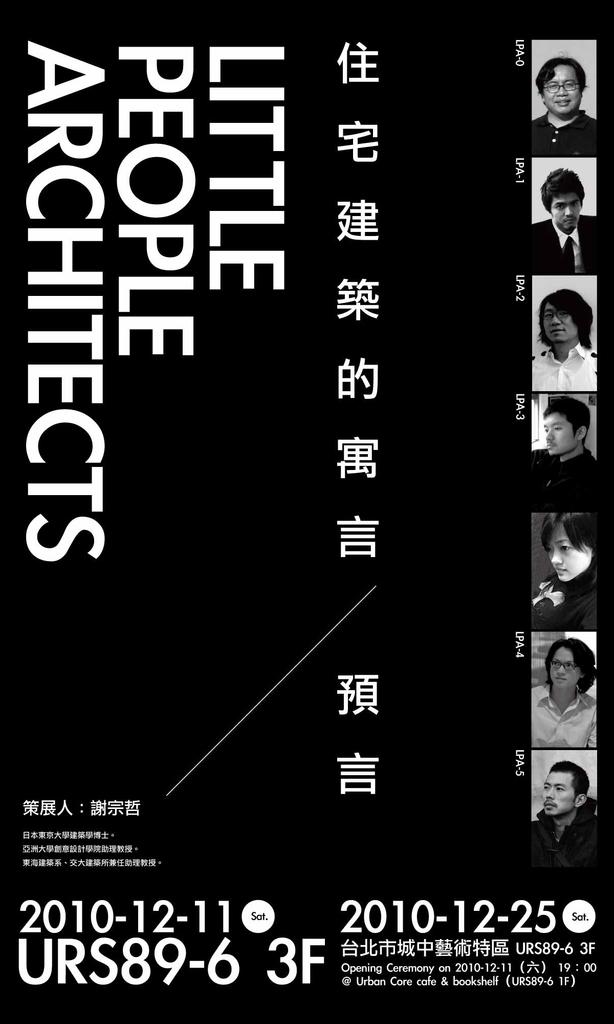What is the ad promoting?
Keep it short and to the point. Little people architects. What year is on the poster?
Your answer should be compact. 2010. 